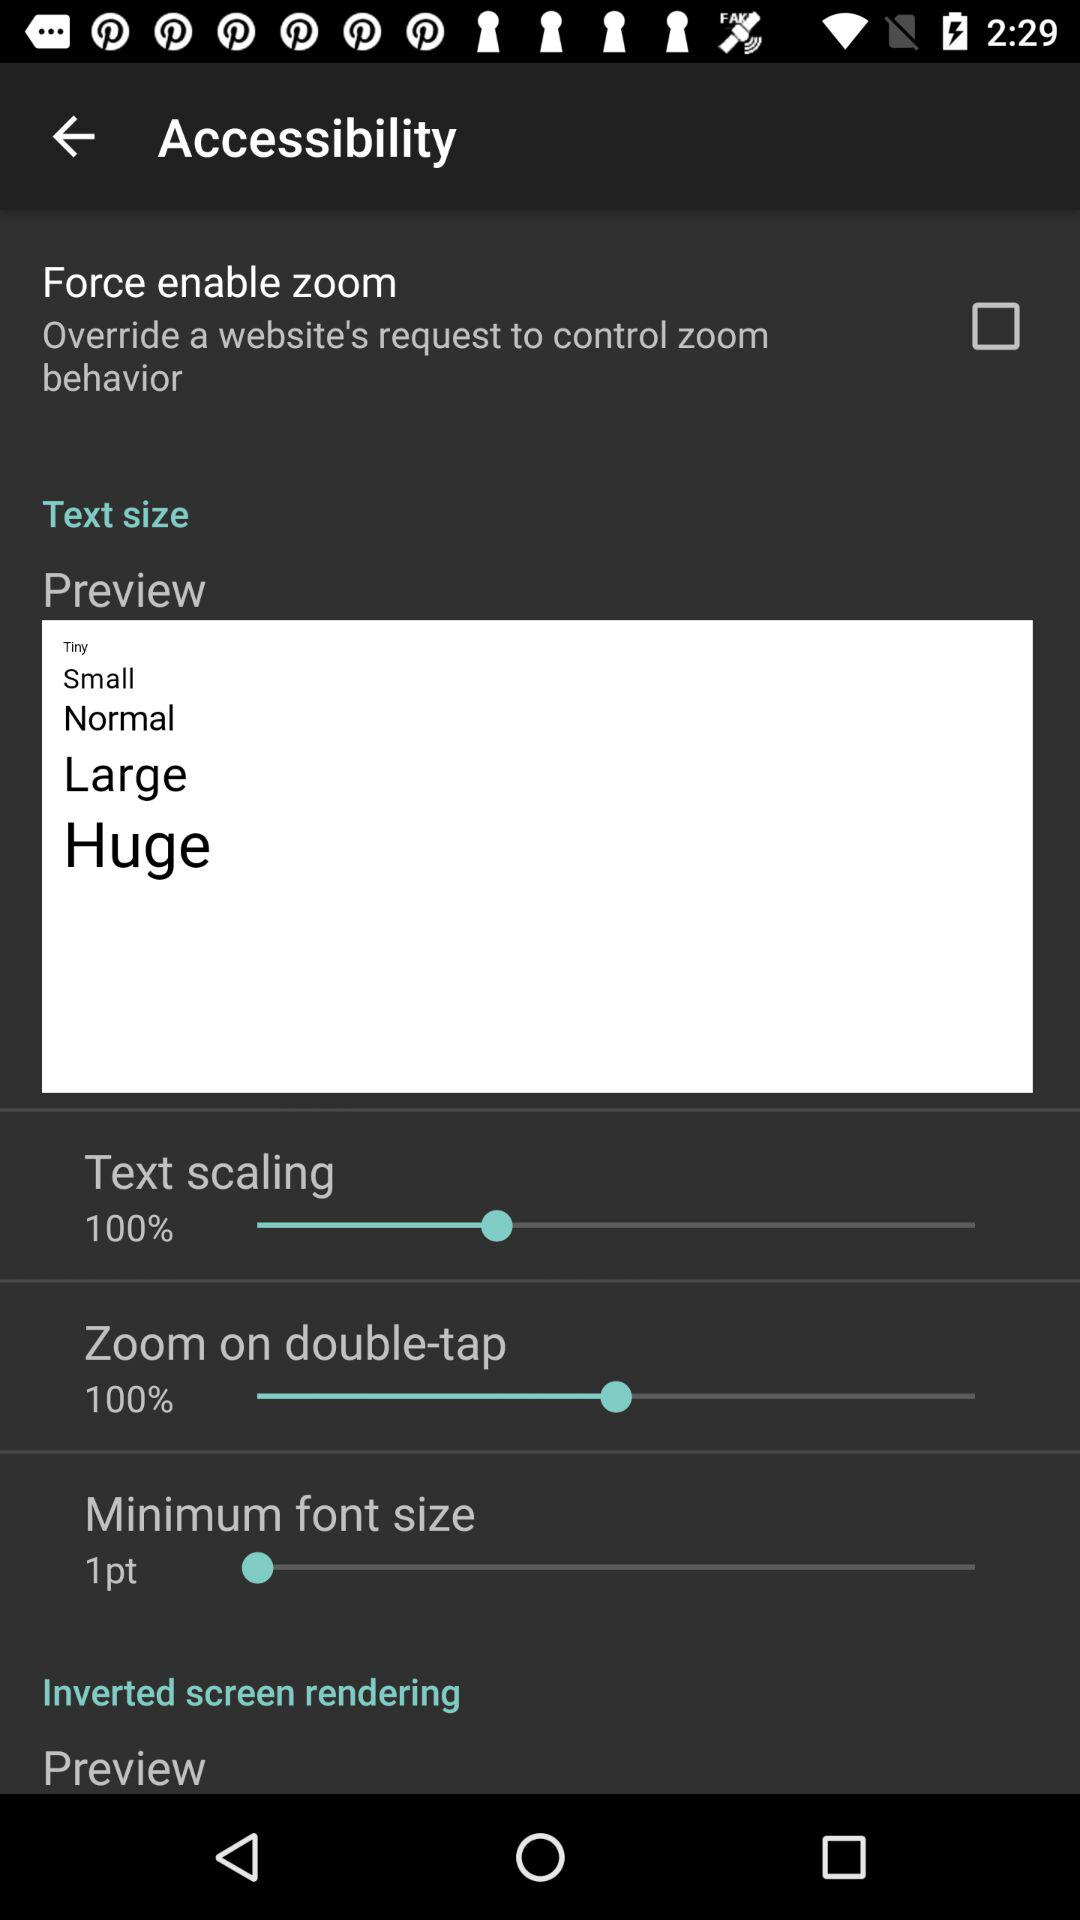What's the percentage of "Zoom on double-tap"? The percentage of "Zoom on double-tap" is 100%. 